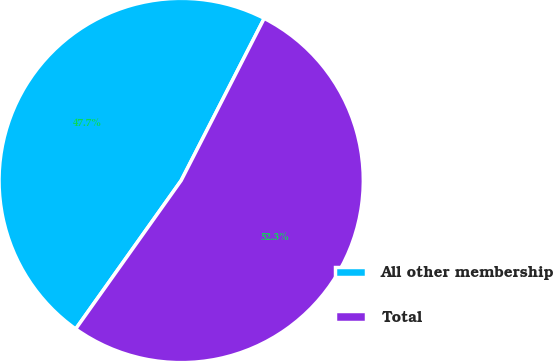Convert chart to OTSL. <chart><loc_0><loc_0><loc_500><loc_500><pie_chart><fcel>All other membership<fcel>Total<nl><fcel>47.7%<fcel>52.3%<nl></chart> 